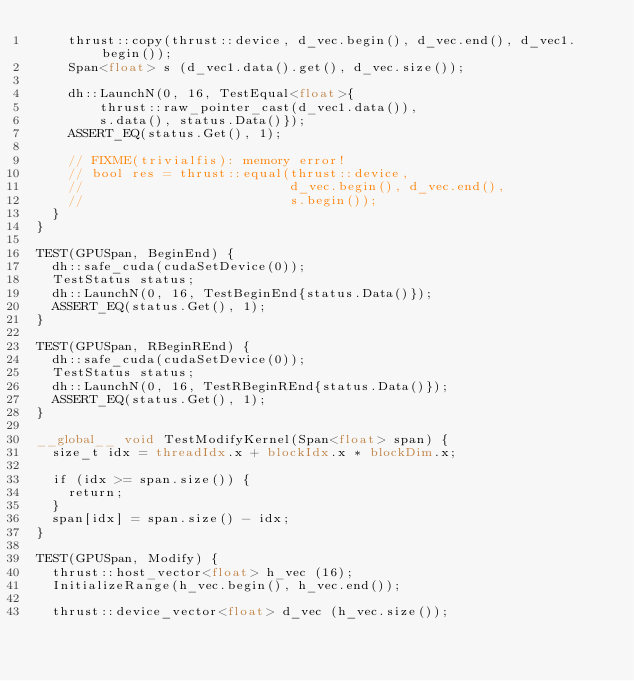<code> <loc_0><loc_0><loc_500><loc_500><_Cuda_>    thrust::copy(thrust::device, d_vec.begin(), d_vec.end(), d_vec1.begin());
    Span<float> s (d_vec1.data().get(), d_vec.size());

    dh::LaunchN(0, 16, TestEqual<float>{
        thrust::raw_pointer_cast(d_vec1.data()),
        s.data(), status.Data()});
    ASSERT_EQ(status.Get(), 1);

    // FIXME(trivialfis): memory error!
    // bool res = thrust::equal(thrust::device,
    //                          d_vec.begin(), d_vec.end(),
    //                          s.begin());
  }
}

TEST(GPUSpan, BeginEnd) {
  dh::safe_cuda(cudaSetDevice(0));
  TestStatus status;
  dh::LaunchN(0, 16, TestBeginEnd{status.Data()});
  ASSERT_EQ(status.Get(), 1);
}

TEST(GPUSpan, RBeginREnd) {
  dh::safe_cuda(cudaSetDevice(0));
  TestStatus status;
  dh::LaunchN(0, 16, TestRBeginREnd{status.Data()});
  ASSERT_EQ(status.Get(), 1);
}

__global__ void TestModifyKernel(Span<float> span) {
  size_t idx = threadIdx.x + blockIdx.x * blockDim.x;

  if (idx >= span.size()) {
    return;
  }
  span[idx] = span.size() - idx;
}

TEST(GPUSpan, Modify) {
  thrust::host_vector<float> h_vec (16);
  InitializeRange(h_vec.begin(), h_vec.end());

  thrust::device_vector<float> d_vec (h_vec.size());</code> 